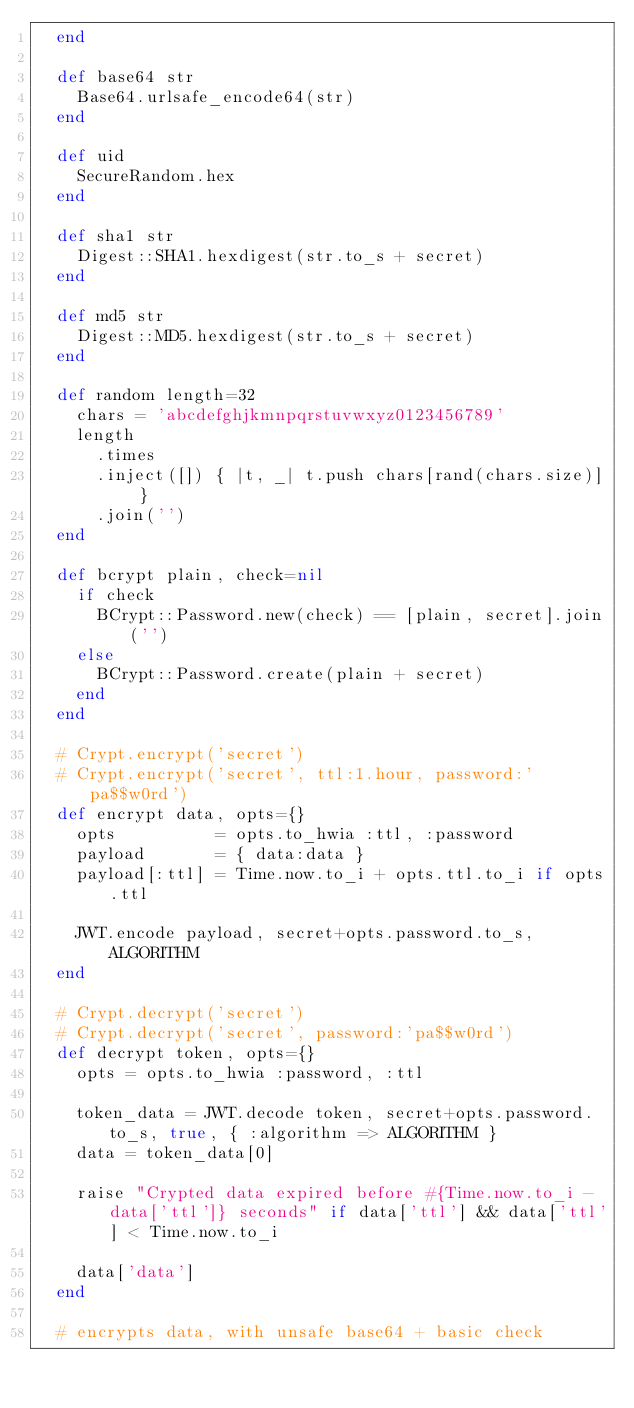Convert code to text. <code><loc_0><loc_0><loc_500><loc_500><_Ruby_>  end

  def base64 str
    Base64.urlsafe_encode64(str)
  end

  def uid
    SecureRandom.hex
  end

  def sha1 str
    Digest::SHA1.hexdigest(str.to_s + secret)
  end

  def md5 str
    Digest::MD5.hexdigest(str.to_s + secret)
  end

  def random length=32
    chars = 'abcdefghjkmnpqrstuvwxyz0123456789'
    length
      .times
      .inject([]) { |t, _| t.push chars[rand(chars.size)] }
      .join('')
  end

  def bcrypt plain, check=nil
    if check
      BCrypt::Password.new(check) == [plain, secret].join('')
    else
      BCrypt::Password.create(plain + secret)
    end
  end

  # Crypt.encrypt('secret')
  # Crypt.encrypt('secret', ttl:1.hour, password:'pa$$w0rd')
  def encrypt data, opts={}
    opts          = opts.to_hwia :ttl, :password
    payload       = { data:data }
    payload[:ttl] = Time.now.to_i + opts.ttl.to_i if opts.ttl

    JWT.encode payload, secret+opts.password.to_s, ALGORITHM
  end

  # Crypt.decrypt('secret')
  # Crypt.decrypt('secret', password:'pa$$w0rd')
  def decrypt token, opts={}
    opts = opts.to_hwia :password, :ttl

    token_data = JWT.decode token, secret+opts.password.to_s, true, { :algorithm => ALGORITHM }
    data = token_data[0]

    raise "Crypted data expired before #{Time.now.to_i - data['ttl']} seconds" if data['ttl'] && data['ttl'] < Time.now.to_i

    data['data']
  end

  # encrypts data, with unsafe base64 + basic check</code> 